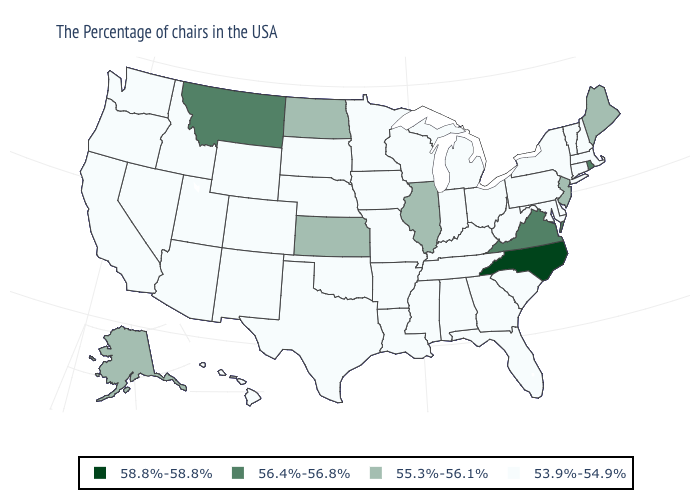Which states have the lowest value in the USA?
Short answer required. Massachusetts, New Hampshire, Vermont, Connecticut, New York, Delaware, Maryland, Pennsylvania, South Carolina, West Virginia, Ohio, Florida, Georgia, Michigan, Kentucky, Indiana, Alabama, Tennessee, Wisconsin, Mississippi, Louisiana, Missouri, Arkansas, Minnesota, Iowa, Nebraska, Oklahoma, Texas, South Dakota, Wyoming, Colorado, New Mexico, Utah, Arizona, Idaho, Nevada, California, Washington, Oregon, Hawaii. What is the value of Idaho?
Quick response, please. 53.9%-54.9%. What is the value of Nebraska?
Give a very brief answer. 53.9%-54.9%. What is the value of Tennessee?
Short answer required. 53.9%-54.9%. Among the states that border Indiana , does Ohio have the lowest value?
Write a very short answer. Yes. Does Montana have the highest value in the West?
Short answer required. Yes. What is the value of Oklahoma?
Write a very short answer. 53.9%-54.9%. Name the states that have a value in the range 56.4%-56.8%?
Be succinct. Rhode Island, Virginia, Montana. Is the legend a continuous bar?
Quick response, please. No. Name the states that have a value in the range 56.4%-56.8%?
Concise answer only. Rhode Island, Virginia, Montana. What is the highest value in the West ?
Quick response, please. 56.4%-56.8%. What is the value of Wyoming?
Concise answer only. 53.9%-54.9%. What is the highest value in states that border Louisiana?
Short answer required. 53.9%-54.9%. 